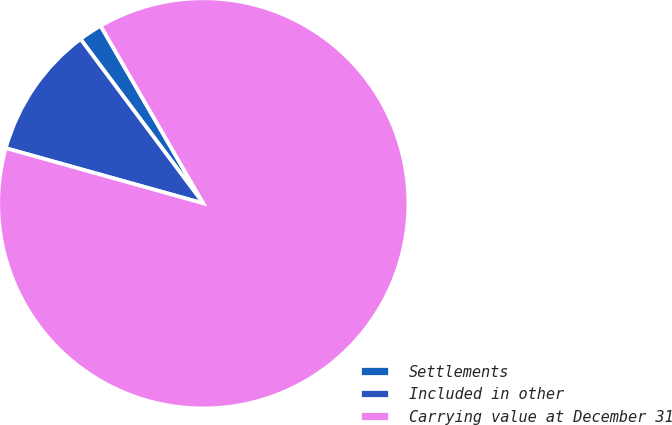Convert chart. <chart><loc_0><loc_0><loc_500><loc_500><pie_chart><fcel>Settlements<fcel>Included in other<fcel>Carrying value at December 31<nl><fcel>1.87%<fcel>10.45%<fcel>87.69%<nl></chart> 